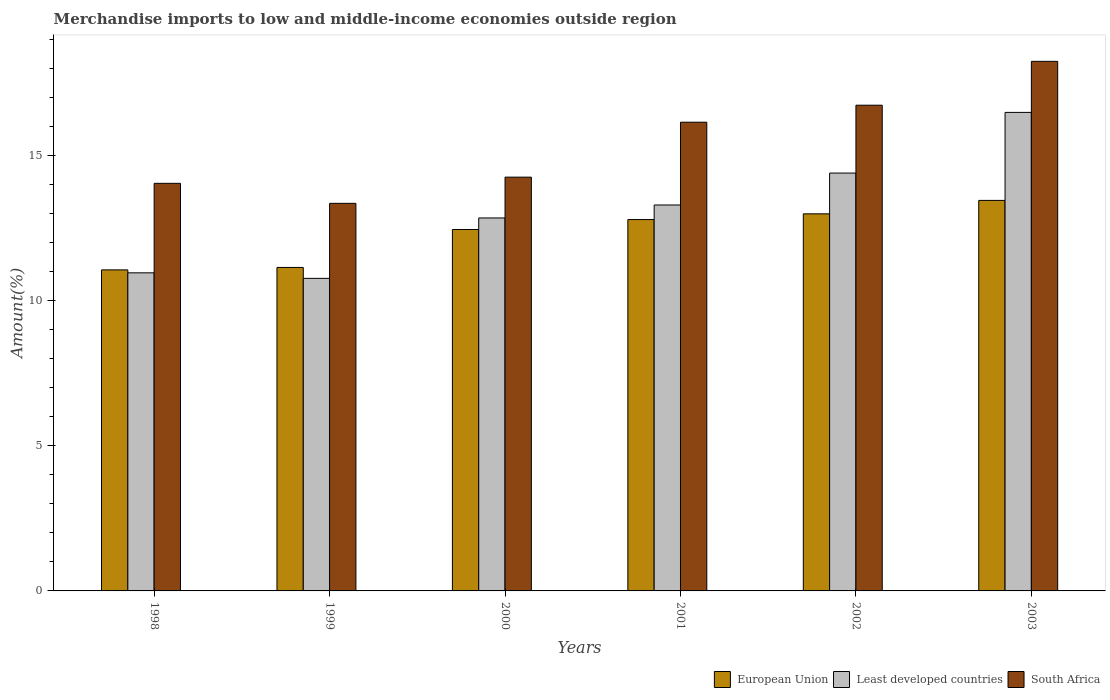Are the number of bars per tick equal to the number of legend labels?
Give a very brief answer. Yes. Are the number of bars on each tick of the X-axis equal?
Your answer should be very brief. Yes. How many bars are there on the 5th tick from the left?
Your response must be concise. 3. How many bars are there on the 6th tick from the right?
Give a very brief answer. 3. In how many cases, is the number of bars for a given year not equal to the number of legend labels?
Provide a succinct answer. 0. What is the percentage of amount earned from merchandise imports in Least developed countries in 2001?
Provide a short and direct response. 13.29. Across all years, what is the maximum percentage of amount earned from merchandise imports in European Union?
Your answer should be compact. 13.45. Across all years, what is the minimum percentage of amount earned from merchandise imports in South Africa?
Make the answer very short. 13.35. In which year was the percentage of amount earned from merchandise imports in Least developed countries maximum?
Your answer should be compact. 2003. What is the total percentage of amount earned from merchandise imports in South Africa in the graph?
Offer a terse response. 92.74. What is the difference between the percentage of amount earned from merchandise imports in Least developed countries in 2001 and that in 2003?
Make the answer very short. -3.19. What is the difference between the percentage of amount earned from merchandise imports in European Union in 2003 and the percentage of amount earned from merchandise imports in South Africa in 2001?
Make the answer very short. -2.69. What is the average percentage of amount earned from merchandise imports in European Union per year?
Offer a very short reply. 12.31. In the year 2000, what is the difference between the percentage of amount earned from merchandise imports in European Union and percentage of amount earned from merchandise imports in South Africa?
Your response must be concise. -1.8. In how many years, is the percentage of amount earned from merchandise imports in South Africa greater than 1 %?
Provide a succinct answer. 6. What is the ratio of the percentage of amount earned from merchandise imports in Least developed countries in 1998 to that in 2002?
Ensure brevity in your answer.  0.76. Is the percentage of amount earned from merchandise imports in South Africa in 2000 less than that in 2001?
Offer a terse response. Yes. Is the difference between the percentage of amount earned from merchandise imports in European Union in 2001 and 2003 greater than the difference between the percentage of amount earned from merchandise imports in South Africa in 2001 and 2003?
Ensure brevity in your answer.  Yes. What is the difference between the highest and the second highest percentage of amount earned from merchandise imports in Least developed countries?
Offer a terse response. 2.09. What is the difference between the highest and the lowest percentage of amount earned from merchandise imports in European Union?
Offer a very short reply. 2.39. In how many years, is the percentage of amount earned from merchandise imports in Least developed countries greater than the average percentage of amount earned from merchandise imports in Least developed countries taken over all years?
Your response must be concise. 3. Is the sum of the percentage of amount earned from merchandise imports in European Union in 2002 and 2003 greater than the maximum percentage of amount earned from merchandise imports in South Africa across all years?
Your response must be concise. Yes. What does the 2nd bar from the left in 1999 represents?
Your response must be concise. Least developed countries. How many bars are there?
Offer a very short reply. 18. Are the values on the major ticks of Y-axis written in scientific E-notation?
Make the answer very short. No. Where does the legend appear in the graph?
Your response must be concise. Bottom right. How are the legend labels stacked?
Offer a terse response. Horizontal. What is the title of the graph?
Keep it short and to the point. Merchandise imports to low and middle-income economies outside region. Does "Latvia" appear as one of the legend labels in the graph?
Offer a terse response. No. What is the label or title of the X-axis?
Keep it short and to the point. Years. What is the label or title of the Y-axis?
Provide a succinct answer. Amount(%). What is the Amount(%) of European Union in 1998?
Ensure brevity in your answer.  11.06. What is the Amount(%) of Least developed countries in 1998?
Give a very brief answer. 10.95. What is the Amount(%) in South Africa in 1998?
Your answer should be very brief. 14.04. What is the Amount(%) of European Union in 1999?
Make the answer very short. 11.14. What is the Amount(%) in Least developed countries in 1999?
Your answer should be compact. 10.76. What is the Amount(%) of South Africa in 1999?
Your answer should be very brief. 13.35. What is the Amount(%) in European Union in 2000?
Offer a very short reply. 12.45. What is the Amount(%) in Least developed countries in 2000?
Provide a short and direct response. 12.84. What is the Amount(%) in South Africa in 2000?
Give a very brief answer. 14.25. What is the Amount(%) of European Union in 2001?
Offer a terse response. 12.79. What is the Amount(%) in Least developed countries in 2001?
Your answer should be compact. 13.29. What is the Amount(%) of South Africa in 2001?
Your answer should be compact. 16.14. What is the Amount(%) in European Union in 2002?
Offer a very short reply. 12.99. What is the Amount(%) in Least developed countries in 2002?
Provide a short and direct response. 14.39. What is the Amount(%) in South Africa in 2002?
Your response must be concise. 16.73. What is the Amount(%) in European Union in 2003?
Your answer should be compact. 13.45. What is the Amount(%) in Least developed countries in 2003?
Provide a succinct answer. 16.48. What is the Amount(%) in South Africa in 2003?
Give a very brief answer. 18.24. Across all years, what is the maximum Amount(%) in European Union?
Your answer should be very brief. 13.45. Across all years, what is the maximum Amount(%) in Least developed countries?
Ensure brevity in your answer.  16.48. Across all years, what is the maximum Amount(%) of South Africa?
Provide a short and direct response. 18.24. Across all years, what is the minimum Amount(%) in European Union?
Offer a very short reply. 11.06. Across all years, what is the minimum Amount(%) of Least developed countries?
Ensure brevity in your answer.  10.76. Across all years, what is the minimum Amount(%) in South Africa?
Your response must be concise. 13.35. What is the total Amount(%) in European Union in the graph?
Provide a short and direct response. 73.87. What is the total Amount(%) in Least developed countries in the graph?
Your response must be concise. 78.72. What is the total Amount(%) of South Africa in the graph?
Give a very brief answer. 92.74. What is the difference between the Amount(%) in European Union in 1998 and that in 1999?
Your answer should be compact. -0.08. What is the difference between the Amount(%) in Least developed countries in 1998 and that in 1999?
Your answer should be compact. 0.19. What is the difference between the Amount(%) of South Africa in 1998 and that in 1999?
Ensure brevity in your answer.  0.69. What is the difference between the Amount(%) of European Union in 1998 and that in 2000?
Ensure brevity in your answer.  -1.39. What is the difference between the Amount(%) of Least developed countries in 1998 and that in 2000?
Provide a succinct answer. -1.89. What is the difference between the Amount(%) of South Africa in 1998 and that in 2000?
Your answer should be compact. -0.21. What is the difference between the Amount(%) in European Union in 1998 and that in 2001?
Your answer should be compact. -1.73. What is the difference between the Amount(%) in Least developed countries in 1998 and that in 2001?
Keep it short and to the point. -2.34. What is the difference between the Amount(%) in South Africa in 1998 and that in 2001?
Your response must be concise. -2.11. What is the difference between the Amount(%) in European Union in 1998 and that in 2002?
Ensure brevity in your answer.  -1.93. What is the difference between the Amount(%) of Least developed countries in 1998 and that in 2002?
Ensure brevity in your answer.  -3.44. What is the difference between the Amount(%) in South Africa in 1998 and that in 2002?
Ensure brevity in your answer.  -2.69. What is the difference between the Amount(%) of European Union in 1998 and that in 2003?
Your answer should be compact. -2.39. What is the difference between the Amount(%) in Least developed countries in 1998 and that in 2003?
Your answer should be very brief. -5.52. What is the difference between the Amount(%) in South Africa in 1998 and that in 2003?
Keep it short and to the point. -4.2. What is the difference between the Amount(%) in European Union in 1999 and that in 2000?
Keep it short and to the point. -1.31. What is the difference between the Amount(%) of Least developed countries in 1999 and that in 2000?
Your response must be concise. -2.08. What is the difference between the Amount(%) in South Africa in 1999 and that in 2000?
Offer a very short reply. -0.9. What is the difference between the Amount(%) in European Union in 1999 and that in 2001?
Make the answer very short. -1.65. What is the difference between the Amount(%) of Least developed countries in 1999 and that in 2001?
Offer a very short reply. -2.53. What is the difference between the Amount(%) in South Africa in 1999 and that in 2001?
Make the answer very short. -2.79. What is the difference between the Amount(%) of European Union in 1999 and that in 2002?
Give a very brief answer. -1.85. What is the difference between the Amount(%) in Least developed countries in 1999 and that in 2002?
Ensure brevity in your answer.  -3.63. What is the difference between the Amount(%) in South Africa in 1999 and that in 2002?
Make the answer very short. -3.38. What is the difference between the Amount(%) of European Union in 1999 and that in 2003?
Ensure brevity in your answer.  -2.31. What is the difference between the Amount(%) in Least developed countries in 1999 and that in 2003?
Provide a short and direct response. -5.72. What is the difference between the Amount(%) in South Africa in 1999 and that in 2003?
Give a very brief answer. -4.89. What is the difference between the Amount(%) in European Union in 2000 and that in 2001?
Offer a terse response. -0.34. What is the difference between the Amount(%) of Least developed countries in 2000 and that in 2001?
Your response must be concise. -0.45. What is the difference between the Amount(%) in South Africa in 2000 and that in 2001?
Your answer should be compact. -1.89. What is the difference between the Amount(%) in European Union in 2000 and that in 2002?
Your response must be concise. -0.54. What is the difference between the Amount(%) of Least developed countries in 2000 and that in 2002?
Make the answer very short. -1.55. What is the difference between the Amount(%) of South Africa in 2000 and that in 2002?
Your answer should be very brief. -2.48. What is the difference between the Amount(%) in European Union in 2000 and that in 2003?
Your answer should be compact. -1. What is the difference between the Amount(%) in Least developed countries in 2000 and that in 2003?
Your response must be concise. -3.63. What is the difference between the Amount(%) in South Africa in 2000 and that in 2003?
Provide a succinct answer. -3.99. What is the difference between the Amount(%) of European Union in 2001 and that in 2002?
Your answer should be very brief. -0.2. What is the difference between the Amount(%) in Least developed countries in 2001 and that in 2002?
Provide a short and direct response. -1.1. What is the difference between the Amount(%) in South Africa in 2001 and that in 2002?
Ensure brevity in your answer.  -0.59. What is the difference between the Amount(%) in European Union in 2001 and that in 2003?
Make the answer very short. -0.66. What is the difference between the Amount(%) in Least developed countries in 2001 and that in 2003?
Your answer should be compact. -3.19. What is the difference between the Amount(%) of South Africa in 2001 and that in 2003?
Your response must be concise. -2.1. What is the difference between the Amount(%) in European Union in 2002 and that in 2003?
Provide a short and direct response. -0.46. What is the difference between the Amount(%) in Least developed countries in 2002 and that in 2003?
Provide a succinct answer. -2.09. What is the difference between the Amount(%) of South Africa in 2002 and that in 2003?
Keep it short and to the point. -1.51. What is the difference between the Amount(%) in European Union in 1998 and the Amount(%) in Least developed countries in 1999?
Make the answer very short. 0.29. What is the difference between the Amount(%) of European Union in 1998 and the Amount(%) of South Africa in 1999?
Offer a terse response. -2.29. What is the difference between the Amount(%) in Least developed countries in 1998 and the Amount(%) in South Africa in 1999?
Keep it short and to the point. -2.39. What is the difference between the Amount(%) in European Union in 1998 and the Amount(%) in Least developed countries in 2000?
Offer a very short reply. -1.79. What is the difference between the Amount(%) in European Union in 1998 and the Amount(%) in South Africa in 2000?
Provide a succinct answer. -3.19. What is the difference between the Amount(%) in Least developed countries in 1998 and the Amount(%) in South Africa in 2000?
Provide a short and direct response. -3.29. What is the difference between the Amount(%) in European Union in 1998 and the Amount(%) in Least developed countries in 2001?
Offer a terse response. -2.23. What is the difference between the Amount(%) in European Union in 1998 and the Amount(%) in South Africa in 2001?
Your answer should be very brief. -5.09. What is the difference between the Amount(%) in Least developed countries in 1998 and the Amount(%) in South Africa in 2001?
Provide a succinct answer. -5.19. What is the difference between the Amount(%) of European Union in 1998 and the Amount(%) of Least developed countries in 2002?
Your answer should be compact. -3.33. What is the difference between the Amount(%) in European Union in 1998 and the Amount(%) in South Africa in 2002?
Offer a very short reply. -5.67. What is the difference between the Amount(%) in Least developed countries in 1998 and the Amount(%) in South Africa in 2002?
Offer a very short reply. -5.77. What is the difference between the Amount(%) in European Union in 1998 and the Amount(%) in Least developed countries in 2003?
Offer a very short reply. -5.42. What is the difference between the Amount(%) in European Union in 1998 and the Amount(%) in South Africa in 2003?
Offer a very short reply. -7.18. What is the difference between the Amount(%) in Least developed countries in 1998 and the Amount(%) in South Africa in 2003?
Keep it short and to the point. -7.28. What is the difference between the Amount(%) in European Union in 1999 and the Amount(%) in Least developed countries in 2000?
Provide a succinct answer. -1.7. What is the difference between the Amount(%) of European Union in 1999 and the Amount(%) of South Africa in 2000?
Your response must be concise. -3.11. What is the difference between the Amount(%) of Least developed countries in 1999 and the Amount(%) of South Africa in 2000?
Provide a succinct answer. -3.49. What is the difference between the Amount(%) of European Union in 1999 and the Amount(%) of Least developed countries in 2001?
Keep it short and to the point. -2.15. What is the difference between the Amount(%) of European Union in 1999 and the Amount(%) of South Africa in 2001?
Ensure brevity in your answer.  -5. What is the difference between the Amount(%) of Least developed countries in 1999 and the Amount(%) of South Africa in 2001?
Offer a terse response. -5.38. What is the difference between the Amount(%) in European Union in 1999 and the Amount(%) in Least developed countries in 2002?
Make the answer very short. -3.25. What is the difference between the Amount(%) in European Union in 1999 and the Amount(%) in South Africa in 2002?
Ensure brevity in your answer.  -5.59. What is the difference between the Amount(%) of Least developed countries in 1999 and the Amount(%) of South Africa in 2002?
Your answer should be very brief. -5.96. What is the difference between the Amount(%) in European Union in 1999 and the Amount(%) in Least developed countries in 2003?
Your response must be concise. -5.34. What is the difference between the Amount(%) of European Union in 1999 and the Amount(%) of South Africa in 2003?
Make the answer very short. -7.1. What is the difference between the Amount(%) of Least developed countries in 1999 and the Amount(%) of South Africa in 2003?
Your response must be concise. -7.47. What is the difference between the Amount(%) in European Union in 2000 and the Amount(%) in Least developed countries in 2001?
Ensure brevity in your answer.  -0.84. What is the difference between the Amount(%) of European Union in 2000 and the Amount(%) of South Africa in 2001?
Your answer should be compact. -3.69. What is the difference between the Amount(%) of Least developed countries in 2000 and the Amount(%) of South Africa in 2001?
Make the answer very short. -3.3. What is the difference between the Amount(%) of European Union in 2000 and the Amount(%) of Least developed countries in 2002?
Your answer should be compact. -1.94. What is the difference between the Amount(%) of European Union in 2000 and the Amount(%) of South Africa in 2002?
Your answer should be very brief. -4.28. What is the difference between the Amount(%) in Least developed countries in 2000 and the Amount(%) in South Africa in 2002?
Provide a succinct answer. -3.88. What is the difference between the Amount(%) of European Union in 2000 and the Amount(%) of Least developed countries in 2003?
Provide a short and direct response. -4.03. What is the difference between the Amount(%) in European Union in 2000 and the Amount(%) in South Africa in 2003?
Make the answer very short. -5.79. What is the difference between the Amount(%) of Least developed countries in 2000 and the Amount(%) of South Africa in 2003?
Provide a short and direct response. -5.39. What is the difference between the Amount(%) of European Union in 2001 and the Amount(%) of Least developed countries in 2002?
Provide a succinct answer. -1.6. What is the difference between the Amount(%) of European Union in 2001 and the Amount(%) of South Africa in 2002?
Provide a short and direct response. -3.94. What is the difference between the Amount(%) of Least developed countries in 2001 and the Amount(%) of South Africa in 2002?
Make the answer very short. -3.44. What is the difference between the Amount(%) in European Union in 2001 and the Amount(%) in Least developed countries in 2003?
Offer a very short reply. -3.69. What is the difference between the Amount(%) in European Union in 2001 and the Amount(%) in South Africa in 2003?
Your response must be concise. -5.45. What is the difference between the Amount(%) of Least developed countries in 2001 and the Amount(%) of South Africa in 2003?
Keep it short and to the point. -4.95. What is the difference between the Amount(%) in European Union in 2002 and the Amount(%) in Least developed countries in 2003?
Provide a succinct answer. -3.49. What is the difference between the Amount(%) of European Union in 2002 and the Amount(%) of South Africa in 2003?
Give a very brief answer. -5.25. What is the difference between the Amount(%) of Least developed countries in 2002 and the Amount(%) of South Africa in 2003?
Your answer should be very brief. -3.85. What is the average Amount(%) of European Union per year?
Provide a short and direct response. 12.31. What is the average Amount(%) of Least developed countries per year?
Provide a short and direct response. 13.12. What is the average Amount(%) of South Africa per year?
Make the answer very short. 15.46. In the year 1998, what is the difference between the Amount(%) of European Union and Amount(%) of Least developed countries?
Offer a very short reply. 0.1. In the year 1998, what is the difference between the Amount(%) of European Union and Amount(%) of South Africa?
Provide a short and direct response. -2.98. In the year 1998, what is the difference between the Amount(%) of Least developed countries and Amount(%) of South Africa?
Your answer should be compact. -3.08. In the year 1999, what is the difference between the Amount(%) in European Union and Amount(%) in Least developed countries?
Offer a terse response. 0.38. In the year 1999, what is the difference between the Amount(%) of European Union and Amount(%) of South Africa?
Your answer should be compact. -2.21. In the year 1999, what is the difference between the Amount(%) in Least developed countries and Amount(%) in South Africa?
Provide a succinct answer. -2.58. In the year 2000, what is the difference between the Amount(%) in European Union and Amount(%) in Least developed countries?
Keep it short and to the point. -0.4. In the year 2000, what is the difference between the Amount(%) of European Union and Amount(%) of South Africa?
Provide a succinct answer. -1.8. In the year 2000, what is the difference between the Amount(%) in Least developed countries and Amount(%) in South Africa?
Provide a succinct answer. -1.4. In the year 2001, what is the difference between the Amount(%) in European Union and Amount(%) in Least developed countries?
Ensure brevity in your answer.  -0.5. In the year 2001, what is the difference between the Amount(%) in European Union and Amount(%) in South Africa?
Offer a terse response. -3.35. In the year 2001, what is the difference between the Amount(%) of Least developed countries and Amount(%) of South Africa?
Provide a short and direct response. -2.85. In the year 2002, what is the difference between the Amount(%) of European Union and Amount(%) of Least developed countries?
Make the answer very short. -1.4. In the year 2002, what is the difference between the Amount(%) in European Union and Amount(%) in South Africa?
Ensure brevity in your answer.  -3.74. In the year 2002, what is the difference between the Amount(%) in Least developed countries and Amount(%) in South Africa?
Offer a very short reply. -2.34. In the year 2003, what is the difference between the Amount(%) of European Union and Amount(%) of Least developed countries?
Your answer should be compact. -3.03. In the year 2003, what is the difference between the Amount(%) of European Union and Amount(%) of South Africa?
Make the answer very short. -4.79. In the year 2003, what is the difference between the Amount(%) of Least developed countries and Amount(%) of South Africa?
Your answer should be compact. -1.76. What is the ratio of the Amount(%) in European Union in 1998 to that in 1999?
Your response must be concise. 0.99. What is the ratio of the Amount(%) of Least developed countries in 1998 to that in 1999?
Offer a terse response. 1.02. What is the ratio of the Amount(%) of South Africa in 1998 to that in 1999?
Ensure brevity in your answer.  1.05. What is the ratio of the Amount(%) of European Union in 1998 to that in 2000?
Give a very brief answer. 0.89. What is the ratio of the Amount(%) in Least developed countries in 1998 to that in 2000?
Provide a succinct answer. 0.85. What is the ratio of the Amount(%) in European Union in 1998 to that in 2001?
Make the answer very short. 0.86. What is the ratio of the Amount(%) of Least developed countries in 1998 to that in 2001?
Your answer should be compact. 0.82. What is the ratio of the Amount(%) of South Africa in 1998 to that in 2001?
Give a very brief answer. 0.87. What is the ratio of the Amount(%) in European Union in 1998 to that in 2002?
Provide a short and direct response. 0.85. What is the ratio of the Amount(%) in Least developed countries in 1998 to that in 2002?
Give a very brief answer. 0.76. What is the ratio of the Amount(%) in South Africa in 1998 to that in 2002?
Provide a succinct answer. 0.84. What is the ratio of the Amount(%) in European Union in 1998 to that in 2003?
Ensure brevity in your answer.  0.82. What is the ratio of the Amount(%) in Least developed countries in 1998 to that in 2003?
Provide a succinct answer. 0.66. What is the ratio of the Amount(%) of South Africa in 1998 to that in 2003?
Offer a terse response. 0.77. What is the ratio of the Amount(%) in European Union in 1999 to that in 2000?
Your response must be concise. 0.9. What is the ratio of the Amount(%) of Least developed countries in 1999 to that in 2000?
Offer a very short reply. 0.84. What is the ratio of the Amount(%) of South Africa in 1999 to that in 2000?
Offer a terse response. 0.94. What is the ratio of the Amount(%) in European Union in 1999 to that in 2001?
Provide a succinct answer. 0.87. What is the ratio of the Amount(%) in Least developed countries in 1999 to that in 2001?
Make the answer very short. 0.81. What is the ratio of the Amount(%) of South Africa in 1999 to that in 2001?
Offer a very short reply. 0.83. What is the ratio of the Amount(%) in European Union in 1999 to that in 2002?
Offer a very short reply. 0.86. What is the ratio of the Amount(%) of Least developed countries in 1999 to that in 2002?
Offer a terse response. 0.75. What is the ratio of the Amount(%) of South Africa in 1999 to that in 2002?
Provide a succinct answer. 0.8. What is the ratio of the Amount(%) of European Union in 1999 to that in 2003?
Keep it short and to the point. 0.83. What is the ratio of the Amount(%) in Least developed countries in 1999 to that in 2003?
Ensure brevity in your answer.  0.65. What is the ratio of the Amount(%) of South Africa in 1999 to that in 2003?
Keep it short and to the point. 0.73. What is the ratio of the Amount(%) in European Union in 2000 to that in 2001?
Give a very brief answer. 0.97. What is the ratio of the Amount(%) in Least developed countries in 2000 to that in 2001?
Provide a succinct answer. 0.97. What is the ratio of the Amount(%) in South Africa in 2000 to that in 2001?
Your response must be concise. 0.88. What is the ratio of the Amount(%) in European Union in 2000 to that in 2002?
Offer a very short reply. 0.96. What is the ratio of the Amount(%) in Least developed countries in 2000 to that in 2002?
Provide a short and direct response. 0.89. What is the ratio of the Amount(%) of South Africa in 2000 to that in 2002?
Provide a short and direct response. 0.85. What is the ratio of the Amount(%) in European Union in 2000 to that in 2003?
Give a very brief answer. 0.93. What is the ratio of the Amount(%) in Least developed countries in 2000 to that in 2003?
Give a very brief answer. 0.78. What is the ratio of the Amount(%) in South Africa in 2000 to that in 2003?
Make the answer very short. 0.78. What is the ratio of the Amount(%) of Least developed countries in 2001 to that in 2002?
Your answer should be very brief. 0.92. What is the ratio of the Amount(%) of European Union in 2001 to that in 2003?
Make the answer very short. 0.95. What is the ratio of the Amount(%) of Least developed countries in 2001 to that in 2003?
Your answer should be compact. 0.81. What is the ratio of the Amount(%) of South Africa in 2001 to that in 2003?
Offer a terse response. 0.89. What is the ratio of the Amount(%) of European Union in 2002 to that in 2003?
Offer a very short reply. 0.97. What is the ratio of the Amount(%) in Least developed countries in 2002 to that in 2003?
Ensure brevity in your answer.  0.87. What is the ratio of the Amount(%) of South Africa in 2002 to that in 2003?
Offer a terse response. 0.92. What is the difference between the highest and the second highest Amount(%) in European Union?
Make the answer very short. 0.46. What is the difference between the highest and the second highest Amount(%) in Least developed countries?
Keep it short and to the point. 2.09. What is the difference between the highest and the second highest Amount(%) of South Africa?
Ensure brevity in your answer.  1.51. What is the difference between the highest and the lowest Amount(%) in European Union?
Offer a terse response. 2.39. What is the difference between the highest and the lowest Amount(%) in Least developed countries?
Make the answer very short. 5.72. What is the difference between the highest and the lowest Amount(%) in South Africa?
Your answer should be compact. 4.89. 